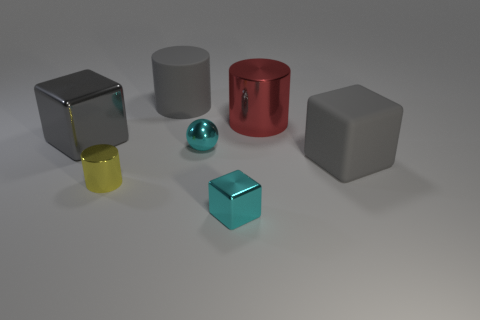There is a red thing; is it the same shape as the big gray object right of the big gray matte cylinder?
Offer a very short reply. No. Is the number of tiny cyan blocks that are on the left side of the large gray matte cylinder less than the number of tiny red matte blocks?
Offer a very short reply. No. There is a yellow thing; are there any metal balls to the left of it?
Provide a short and direct response. No. Are there any other metal objects that have the same shape as the small yellow object?
Make the answer very short. Yes. What shape is the cyan metal thing that is the same size as the cyan block?
Your response must be concise. Sphere. How many objects are either things to the left of the small metallic cube or large gray cubes?
Provide a short and direct response. 5. Is the color of the big metal cube the same as the large rubber block?
Offer a terse response. Yes. What size is the cyan object behind the small cyan shiny block?
Keep it short and to the point. Small. Is there a cyan metallic ball of the same size as the yellow shiny thing?
Provide a short and direct response. Yes. There is a cyan metal thing behind the yellow shiny cylinder; is it the same size as the matte cylinder?
Your answer should be compact. No. 